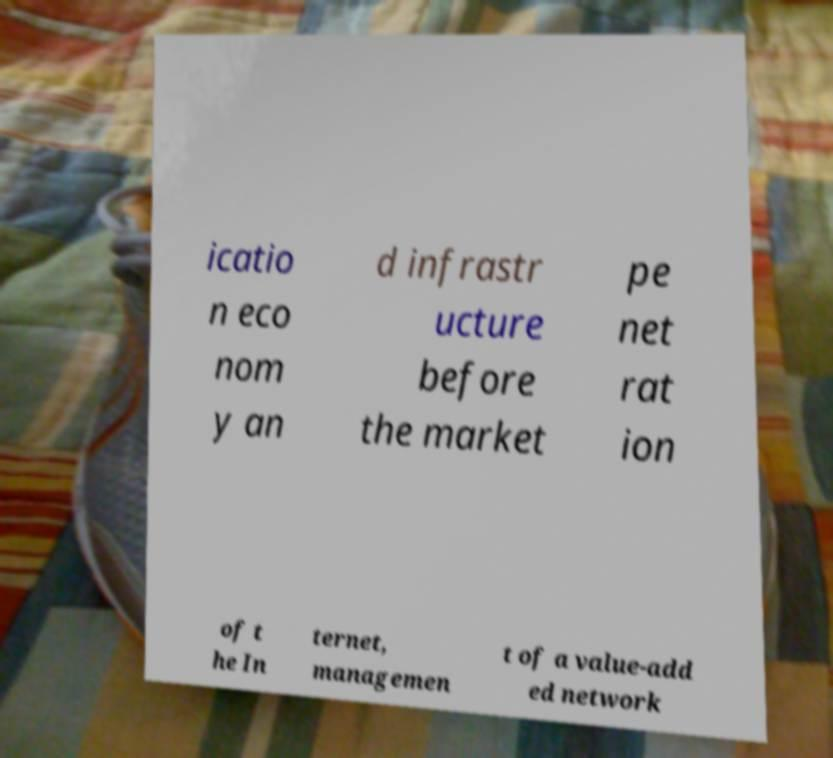What messages or text are displayed in this image? I need them in a readable, typed format. icatio n eco nom y an d infrastr ucture before the market pe net rat ion of t he In ternet, managemen t of a value-add ed network 